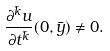<formula> <loc_0><loc_0><loc_500><loc_500>\frac { \partial ^ { \bar { k } } u } { \partial t ^ { \bar { k } } } ( 0 , \bar { y } ) \ne 0 .</formula> 